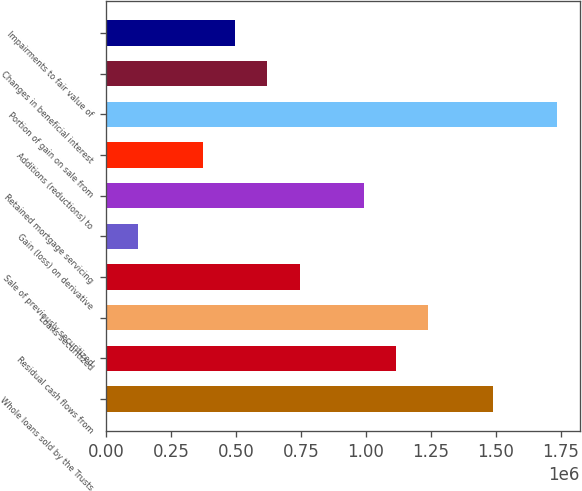<chart> <loc_0><loc_0><loc_500><loc_500><bar_chart><fcel>Whole loans sold by the Trusts<fcel>Residual cash flows from<fcel>Loans securitized<fcel>Sale of previously securitized<fcel>Gain (loss) on derivative<fcel>Retained mortgage servicing<fcel>Additions (reductions) to<fcel>Portion of gain on sale from<fcel>Changes in beneficial interest<fcel>Impairments to fair value of<nl><fcel>1.48923e+06<fcel>1.11694e+06<fcel>1.24104e+06<fcel>744660<fcel>124187<fcel>992850<fcel>372376<fcel>1.73742e+06<fcel>620566<fcel>496471<nl></chart> 